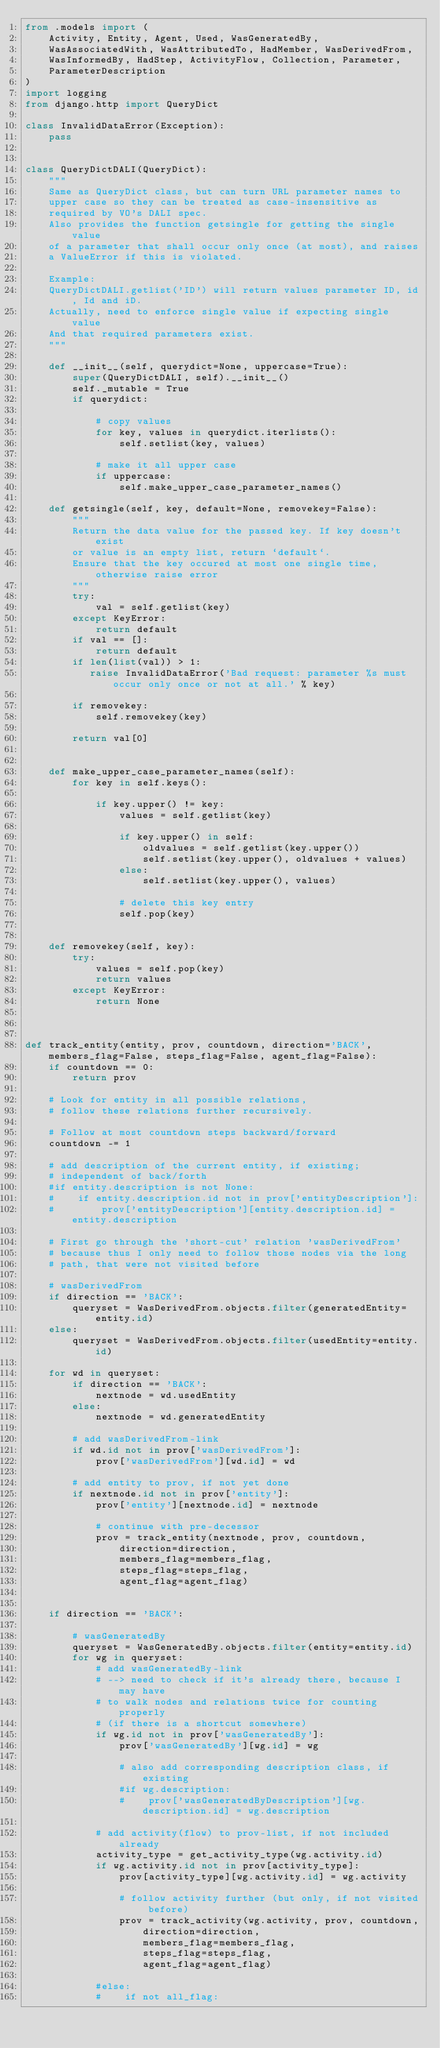<code> <loc_0><loc_0><loc_500><loc_500><_Python_>from .models import (
    Activity, Entity, Agent, Used, WasGeneratedBy,
    WasAssociatedWith, WasAttributedTo, HadMember, WasDerivedFrom,
    WasInformedBy, HadStep, ActivityFlow, Collection, Parameter,
    ParameterDescription
)
import logging
from django.http import QueryDict

class InvalidDataError(Exception):
    pass


class QueryDictDALI(QueryDict):
    """
    Same as QueryDict class, but can turn URL parameter names to
    upper case so they can be treated as case-insensitive as
    required by VO's DALI spec.
    Also provides the function getsingle for getting the single value
    of a parameter that shall occur only once (at most), and raises
    a ValueError if this is violated.

    Example:
    QueryDictDALI.getlist('ID') will return values parameter ID, id, Id and iD.
    Actually, need to enforce single value if expecting single value
    And that required parameters exist.
    """

    def __init__(self, querydict=None, uppercase=True):
        super(QueryDictDALI, self).__init__()
        self._mutable = True
        if querydict:

            # copy values
            for key, values in querydict.iterlists():
                self.setlist(key, values)

            # make it all upper case
            if uppercase:
                self.make_upper_case_parameter_names()

    def getsingle(self, key, default=None, removekey=False):
        """
        Return the data value for the passed key. If key doesn't exist
        or value is an empty list, return `default`.
        Ensure that the key occured at most one single time, otherwise raise error
        """
        try:
            val = self.getlist(key)
        except KeyError:
            return default
        if val == []:
            return default
        if len(list(val)) > 1:
           raise InvalidDataError('Bad request: parameter %s must occur only once or not at all.' % key)

        if removekey:
            self.removekey(key)

        return val[0]


    def make_upper_case_parameter_names(self):
        for key in self.keys():

            if key.upper() != key:
                values = self.getlist(key)

                if key.upper() in self:
                    oldvalues = self.getlist(key.upper())
                    self.setlist(key.upper(), oldvalues + values)
                else:
                    self.setlist(key.upper(), values)

                # delete this key entry
                self.pop(key)


    def removekey(self, key):
        try:
            values = self.pop(key)
            return values
        except KeyError:
            return None



def track_entity(entity, prov, countdown, direction='BACK', members_flag=False, steps_flag=False, agent_flag=False):
    if countdown == 0:
        return prov

    # Look for entity in all possible relations,
    # follow these relations further recursively.

    # Follow at most countdown steps backward/forward
    countdown -= 1

    # add description of the current entity, if existing;
    # independent of back/forth
    #if entity.description is not None:
    #    if entity.description.id not in prov['entityDescription']:
    #        prov['entityDescription'][entity.description.id] = entity.description

    # First go through the 'short-cut' relation 'wasDerivedFrom'
    # because thus I only need to follow those nodes via the long
    # path, that were not visited before

    # wasDerivedFrom
    if direction == 'BACK':
        queryset = WasDerivedFrom.objects.filter(generatedEntity=entity.id)
    else:
        queryset = WasDerivedFrom.objects.filter(usedEntity=entity.id)

    for wd in queryset:
        if direction == 'BACK':
            nextnode = wd.usedEntity
        else:
            nextnode = wd.generatedEntity

        # add wasDerivedFrom-link
        if wd.id not in prov['wasDerivedFrom']:
            prov['wasDerivedFrom'][wd.id] = wd

        # add entity to prov, if not yet done
        if nextnode.id not in prov['entity']:
            prov['entity'][nextnode.id] = nextnode

            # continue with pre-decessor
            prov = track_entity(nextnode, prov, countdown,
                direction=direction,
                members_flag=members_flag,
                steps_flag=steps_flag,
                agent_flag=agent_flag)


    if direction == 'BACK':

        # wasGeneratedBy
        queryset = WasGeneratedBy.objects.filter(entity=entity.id)
        for wg in queryset:
            # add wasGeneratedBy-link
            # --> need to check if it's already there, because I may have
            # to walk nodes and relations twice for counting properly
            # (if there is a shortcut somewhere)
            if wg.id not in prov['wasGeneratedBy']:
                prov['wasGeneratedBy'][wg.id] = wg

                # also add corresponding description class, if existing
                #if wg.description:
                #    prov['wasGeneratedByDescription'][wg.description.id] = wg.description

            # add activity(flow) to prov-list, if not included already
            activity_type = get_activity_type(wg.activity.id)
            if wg.activity.id not in prov[activity_type]:
                prov[activity_type][wg.activity.id] = wg.activity

                # follow activity further (but only, if not visited before)
                prov = track_activity(wg.activity, prov, countdown,
                    direction=direction,
                    members_flag=members_flag,
                    steps_flag=steps_flag,
                    agent_flag=agent_flag)

            #else:
            #    if not all_flag:</code> 